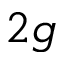Convert formula to latex. <formula><loc_0><loc_0><loc_500><loc_500>{ 2 g }</formula> 